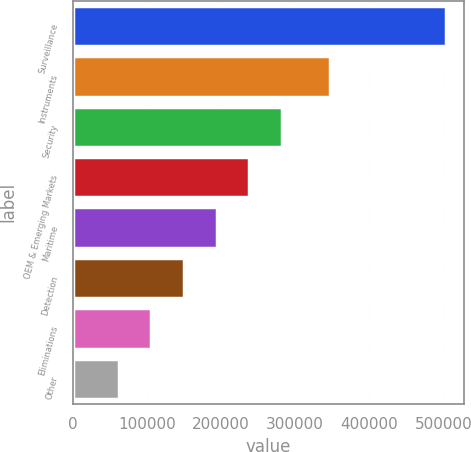Convert chart to OTSL. <chart><loc_0><loc_0><loc_500><loc_500><bar_chart><fcel>Surveillance<fcel>Instruments<fcel>Security<fcel>OEM & Emerging Markets<fcel>Maritime<fcel>Detection<fcel>Eliminations<fcel>Other<nl><fcel>503045<fcel>347476<fcel>282496<fcel>238386<fcel>194276<fcel>150166<fcel>106056<fcel>61946<nl></chart> 